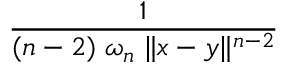<formula> <loc_0><loc_0><loc_500><loc_500>\frac { 1 } { ( n - 2 ) \, \omega _ { n } \, \| x - y \| ^ { n - 2 } }</formula> 